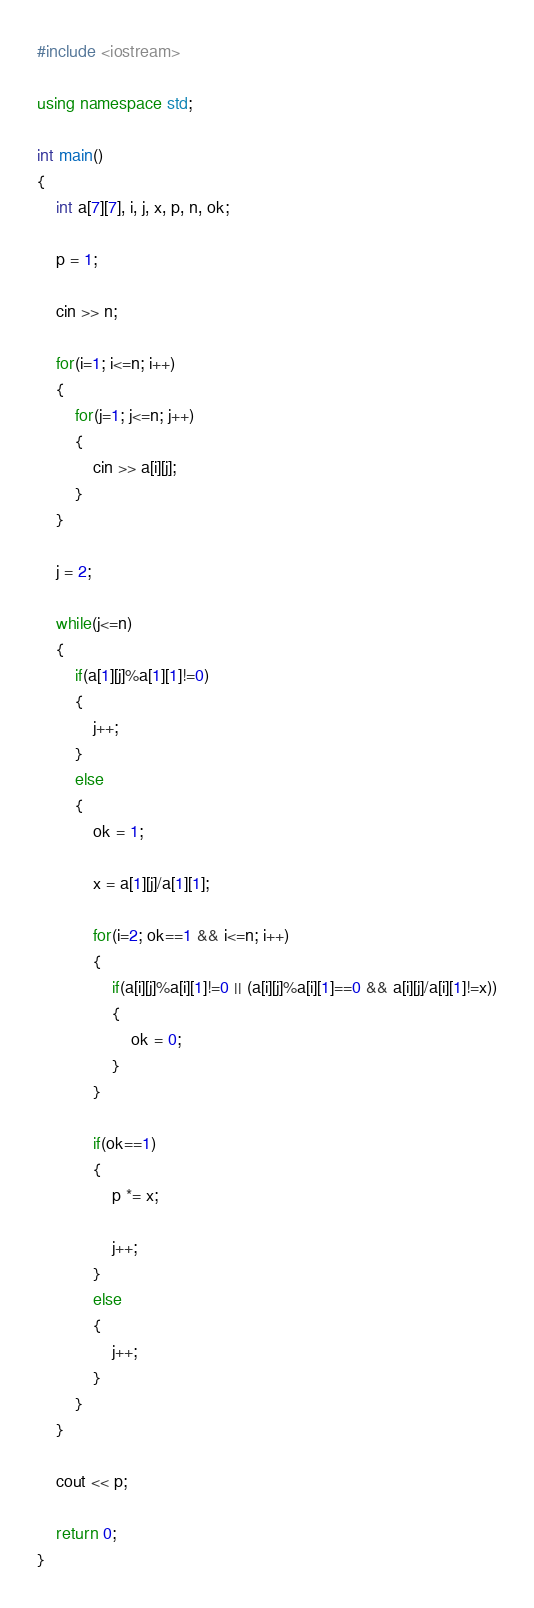<code> <loc_0><loc_0><loc_500><loc_500><_C++_>#include <iostream>

using namespace std;

int main()
{
    int a[7][7], i, j, x, p, n, ok;

    p = 1;

    cin >> n;

    for(i=1; i<=n; i++)
    {
        for(j=1; j<=n; j++)
        {
            cin >> a[i][j];
        }
    }

    j = 2;

    while(j<=n)
    {
        if(a[1][j]%a[1][1]!=0)
        {
            j++;
        }
        else
        {
            ok = 1;

            x = a[1][j]/a[1][1];

            for(i=2; ok==1 && i<=n; i++)
            {
                if(a[i][j]%a[i][1]!=0 || (a[i][j]%a[i][1]==0 && a[i][j]/a[i][1]!=x))
                {
                    ok = 0;
                }
            }

            if(ok==1)
            {
                p *= x;

                j++;
            }
            else
            {
                j++;
            }
        }
    }

    cout << p;

    return 0;
}
</code> 